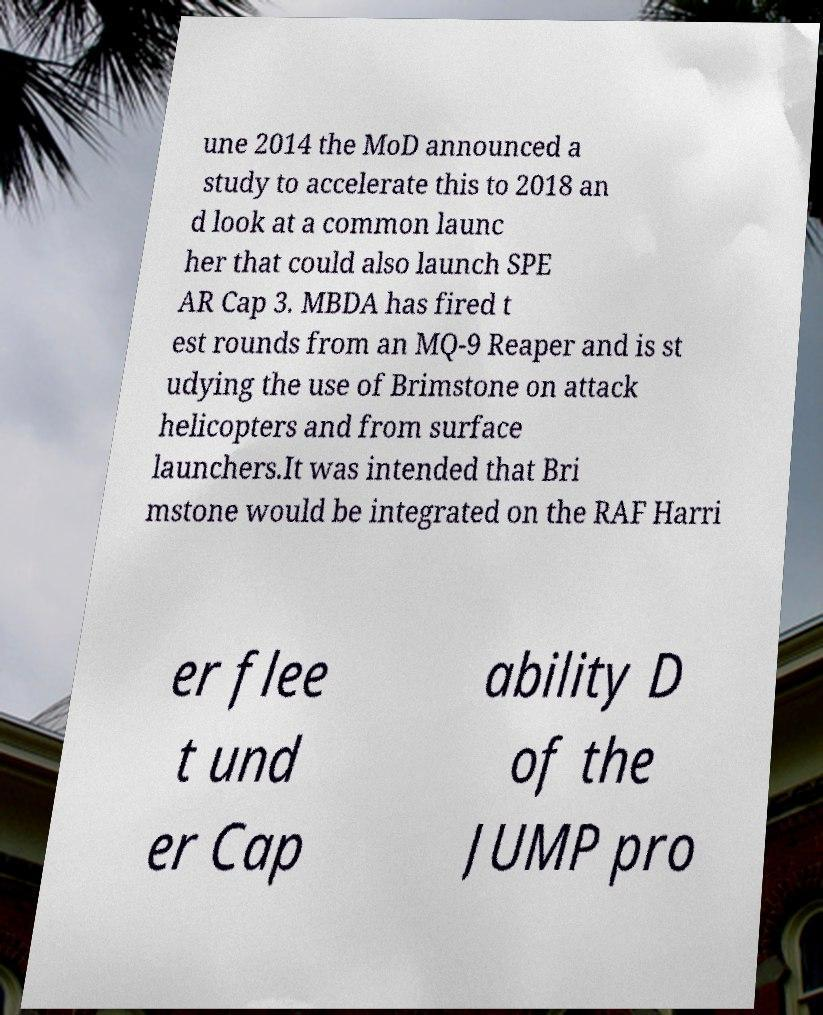Please identify and transcribe the text found in this image. une 2014 the MoD announced a study to accelerate this to 2018 an d look at a common launc her that could also launch SPE AR Cap 3. MBDA has fired t est rounds from an MQ-9 Reaper and is st udying the use of Brimstone on attack helicopters and from surface launchers.It was intended that Bri mstone would be integrated on the RAF Harri er flee t und er Cap ability D of the JUMP pro 